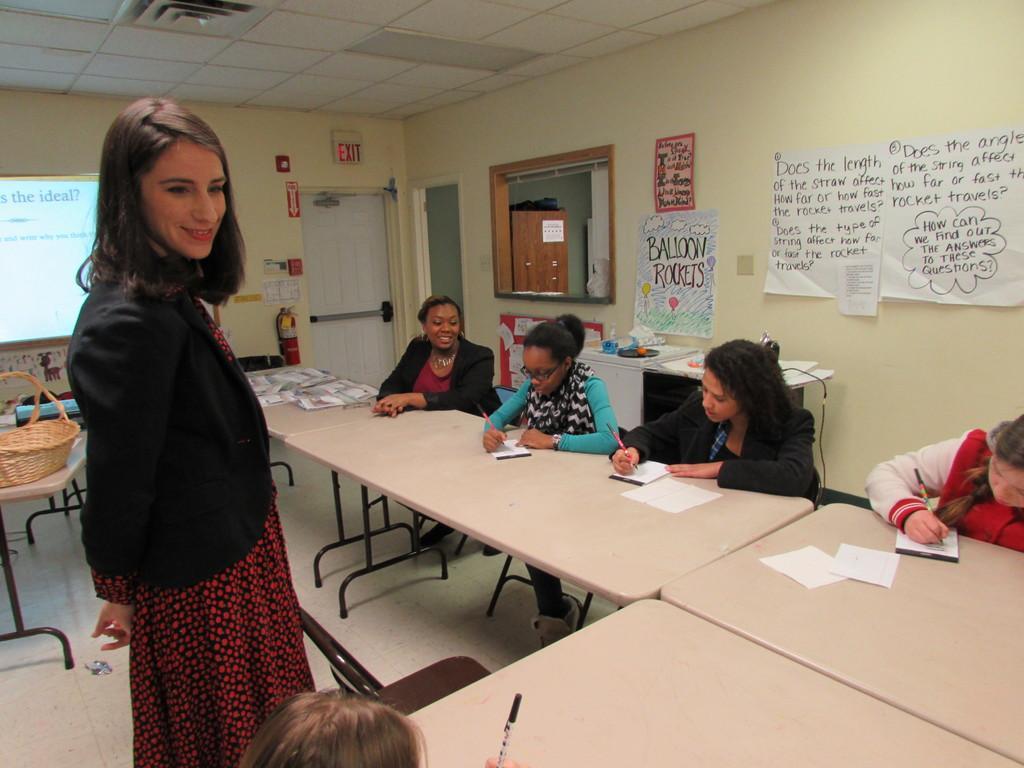Can you describe this image briefly? As we can see in the image there is a wall, window, door, screen, few people sitting over here and there are chairs and tables. On table there is a basket, papers and on the left side there is a women standing. 